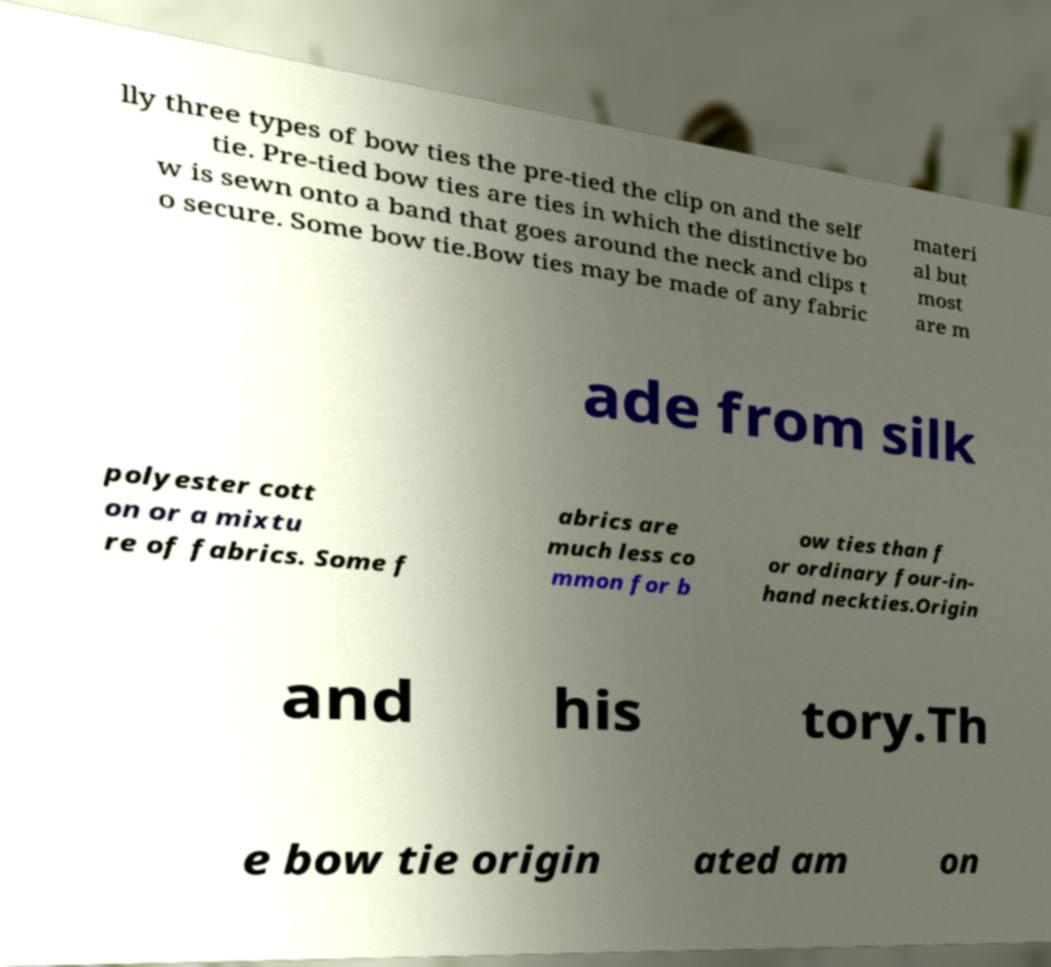Can you accurately transcribe the text from the provided image for me? lly three types of bow ties the pre-tied the clip on and the self tie. Pre-tied bow ties are ties in which the distinctive bo w is sewn onto a band that goes around the neck and clips t o secure. Some bow tie.Bow ties may be made of any fabric materi al but most are m ade from silk polyester cott on or a mixtu re of fabrics. Some f abrics are much less co mmon for b ow ties than f or ordinary four-in- hand neckties.Origin and his tory.Th e bow tie origin ated am on 